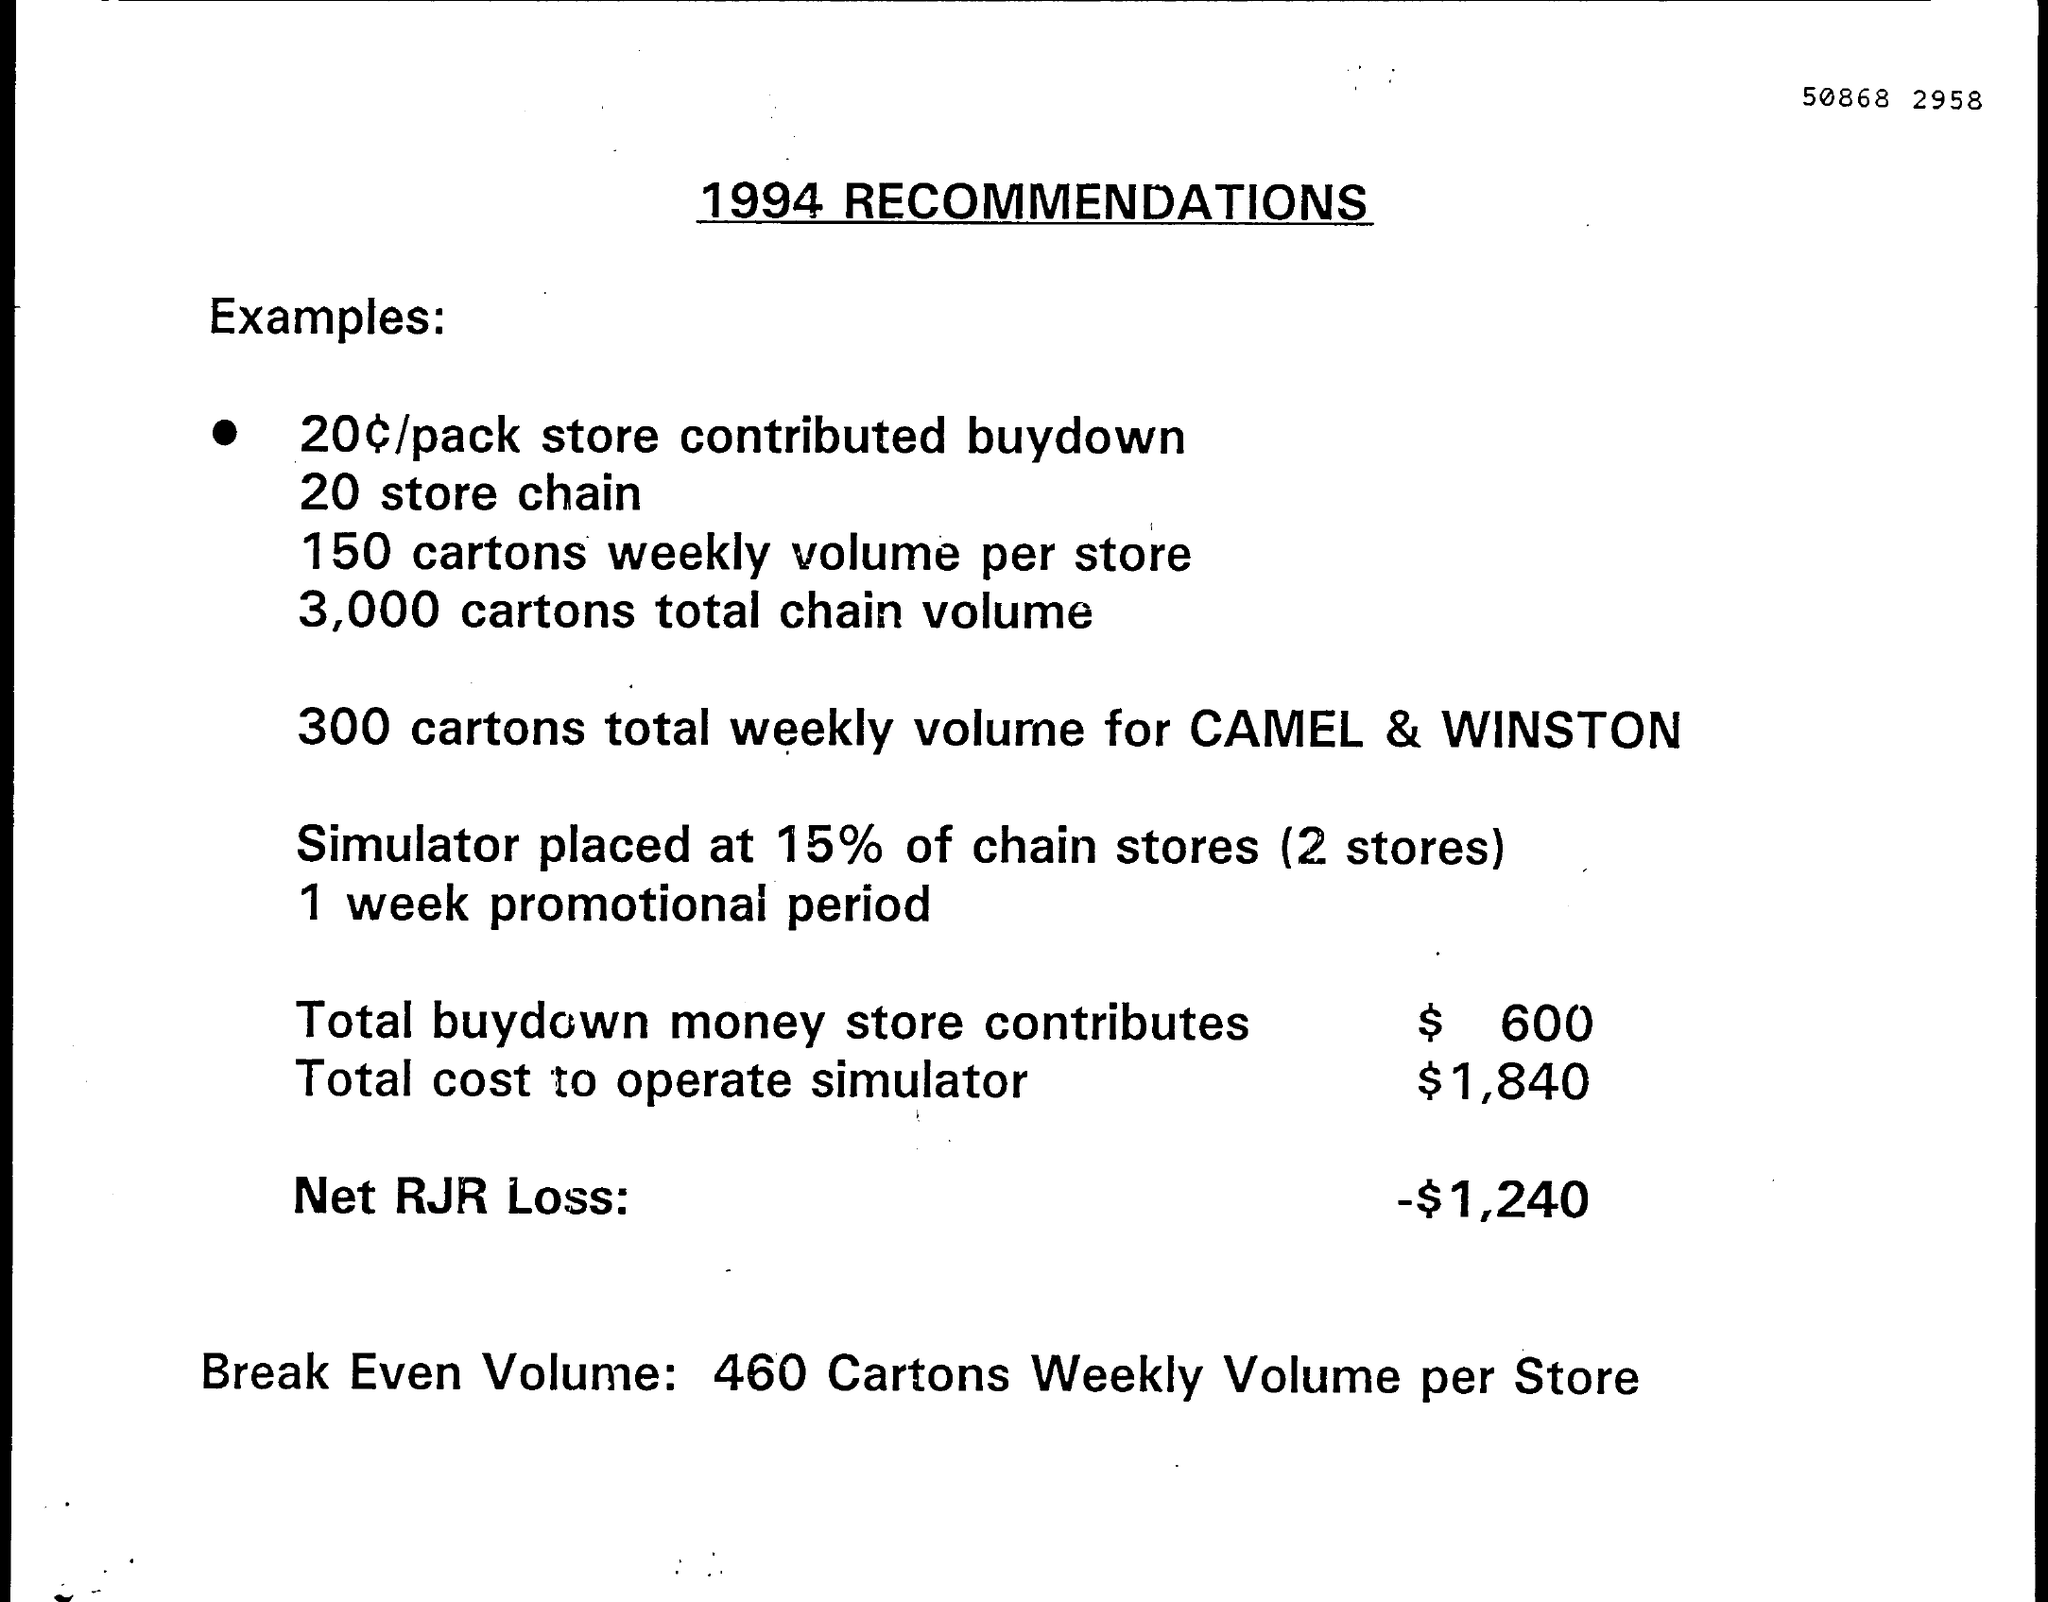List a handful of essential elements in this visual. The total amount of money that the store contributes towards the buydown is $600. The total cost to operate the simulator is $1,840. The break-even volume for each store is 460 cartons per week, as stated in the document. The net RJR loss is -$1,240. 